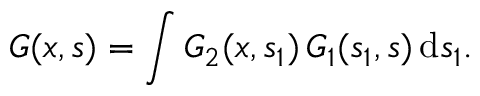Convert formula to latex. <formula><loc_0><loc_0><loc_500><loc_500>G ( x , s ) = \int G _ { 2 } ( x , s _ { 1 } ) \, G _ { 1 } ( s _ { 1 } , s ) \, d s _ { 1 } .</formula> 